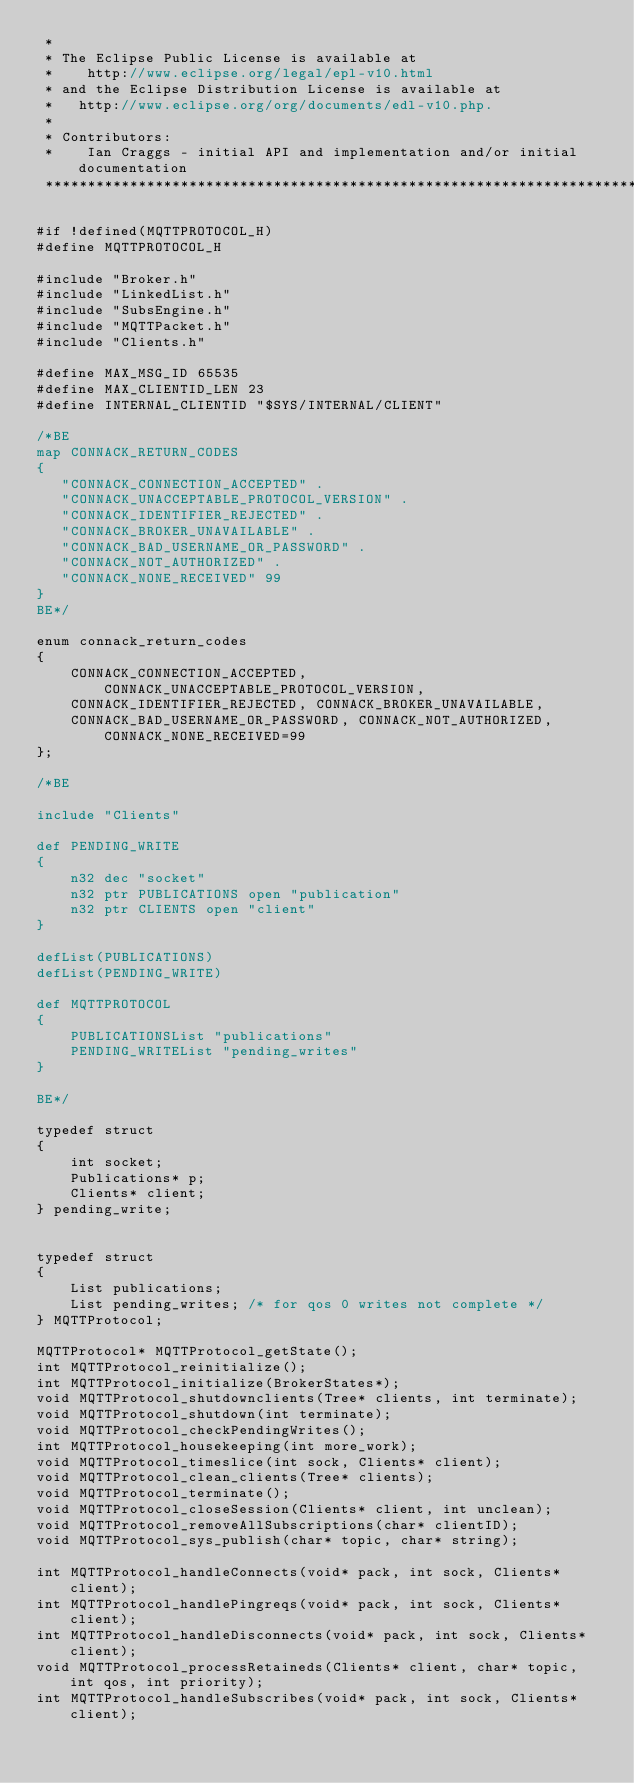Convert code to text. <code><loc_0><loc_0><loc_500><loc_500><_C_> *
 * The Eclipse Public License is available at 
 *    http://www.eclipse.org/legal/epl-v10.html
 * and the Eclipse Distribution License is available at 
 *   http://www.eclipse.org/org/documents/edl-v10.php.
 *
 * Contributors:
 *    Ian Craggs - initial API and implementation and/or initial documentation
 *******************************************************************************/

#if !defined(MQTTPROTOCOL_H)
#define MQTTPROTOCOL_H

#include "Broker.h"
#include "LinkedList.h"
#include "SubsEngine.h"
#include "MQTTPacket.h"
#include "Clients.h"

#define MAX_MSG_ID 65535
#define MAX_CLIENTID_LEN 23
#define INTERNAL_CLIENTID "$SYS/INTERNAL/CLIENT"

/*BE
map CONNACK_RETURN_CODES
{
   "CONNACK_CONNECTION_ACCEPTED" .
   "CONNACK_UNACCEPTABLE_PROTOCOL_VERSION" .
   "CONNACK_IDENTIFIER_REJECTED" .
   "CONNACK_BROKER_UNAVAILABLE" .
   "CONNACK_BAD_USERNAME_OR_PASSWORD" .
   "CONNACK_NOT_AUTHORIZED" .
   "CONNACK_NONE_RECEIVED" 99
}
BE*/

enum connack_return_codes
{
	CONNACK_CONNECTION_ACCEPTED, CONNACK_UNACCEPTABLE_PROTOCOL_VERSION,
	CONNACK_IDENTIFIER_REJECTED, CONNACK_BROKER_UNAVAILABLE,
	CONNACK_BAD_USERNAME_OR_PASSWORD, CONNACK_NOT_AUTHORIZED, CONNACK_NONE_RECEIVED=99
};

/*BE

include "Clients"

def PENDING_WRITE
{
	n32 dec "socket"
	n32 ptr PUBLICATIONS open "publication"
	n32 ptr CLIENTS open "client"
}

defList(PUBLICATIONS)
defList(PENDING_WRITE)

def MQTTPROTOCOL
{
	PUBLICATIONSList "publications"
	PENDING_WRITEList "pending_writes"
}

BE*/

typedef struct
{
	int socket;
	Publications* p;
	Clients* client;
} pending_write;


typedef struct
{
	List publications;
	List pending_writes; /* for qos 0 writes not complete */
} MQTTProtocol;

MQTTProtocol* MQTTProtocol_getState();
int MQTTProtocol_reinitialize();
int MQTTProtocol_initialize(BrokerStates*);
void MQTTProtocol_shutdownclients(Tree* clients, int terminate);
void MQTTProtocol_shutdown(int terminate);
void MQTTProtocol_checkPendingWrites();
int MQTTProtocol_housekeeping(int more_work);
void MQTTProtocol_timeslice(int sock, Clients* client);
void MQTTProtocol_clean_clients(Tree* clients);
void MQTTProtocol_terminate();
void MQTTProtocol_closeSession(Clients* client, int unclean);
void MQTTProtocol_removeAllSubscriptions(char* clientID);
void MQTTProtocol_sys_publish(char* topic, char* string);

int MQTTProtocol_handleConnects(void* pack, int sock, Clients* client);
int MQTTProtocol_handlePingreqs(void* pack, int sock, Clients* client);
int MQTTProtocol_handleDisconnects(void* pack, int sock, Clients* client);
void MQTTProtocol_processRetaineds(Clients* client, char* topic, int qos, int priority);
int MQTTProtocol_handleSubscribes(void* pack, int sock, Clients* client);</code> 